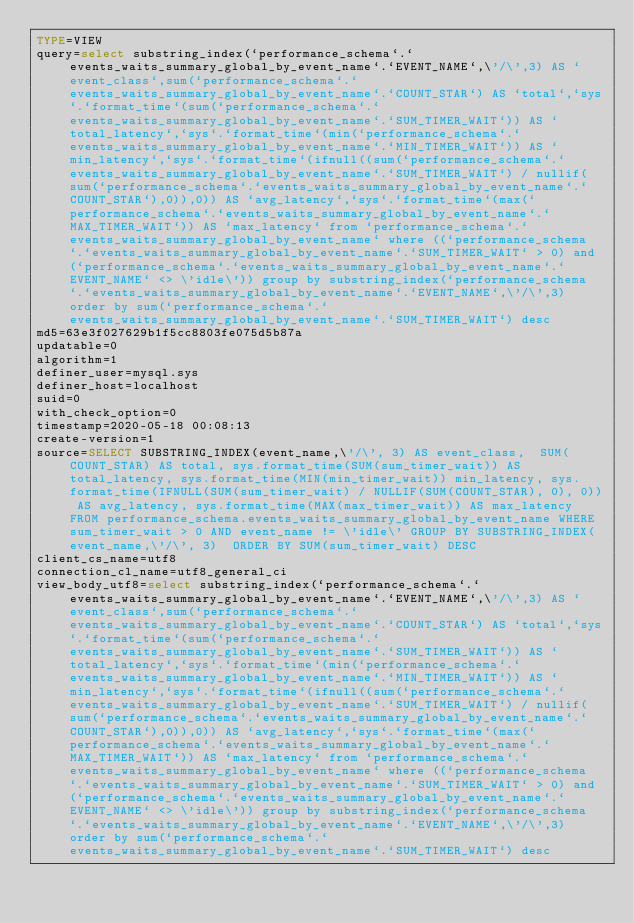Convert code to text. <code><loc_0><loc_0><loc_500><loc_500><_VisualBasic_>TYPE=VIEW
query=select substring_index(`performance_schema`.`events_waits_summary_global_by_event_name`.`EVENT_NAME`,\'/\',3) AS `event_class`,sum(`performance_schema`.`events_waits_summary_global_by_event_name`.`COUNT_STAR`) AS `total`,`sys`.`format_time`(sum(`performance_schema`.`events_waits_summary_global_by_event_name`.`SUM_TIMER_WAIT`)) AS `total_latency`,`sys`.`format_time`(min(`performance_schema`.`events_waits_summary_global_by_event_name`.`MIN_TIMER_WAIT`)) AS `min_latency`,`sys`.`format_time`(ifnull((sum(`performance_schema`.`events_waits_summary_global_by_event_name`.`SUM_TIMER_WAIT`) / nullif(sum(`performance_schema`.`events_waits_summary_global_by_event_name`.`COUNT_STAR`),0)),0)) AS `avg_latency`,`sys`.`format_time`(max(`performance_schema`.`events_waits_summary_global_by_event_name`.`MAX_TIMER_WAIT`)) AS `max_latency` from `performance_schema`.`events_waits_summary_global_by_event_name` where ((`performance_schema`.`events_waits_summary_global_by_event_name`.`SUM_TIMER_WAIT` > 0) and (`performance_schema`.`events_waits_summary_global_by_event_name`.`EVENT_NAME` <> \'idle\')) group by substring_index(`performance_schema`.`events_waits_summary_global_by_event_name`.`EVENT_NAME`,\'/\',3) order by sum(`performance_schema`.`events_waits_summary_global_by_event_name`.`SUM_TIMER_WAIT`) desc
md5=63e3f027629b1f5cc8803fe075d5b87a
updatable=0
algorithm=1
definer_user=mysql.sys
definer_host=localhost
suid=0
with_check_option=0
timestamp=2020-05-18 00:08:13
create-version=1
source=SELECT SUBSTRING_INDEX(event_name,\'/\', 3) AS event_class,  SUM(COUNT_STAR) AS total, sys.format_time(SUM(sum_timer_wait)) AS total_latency, sys.format_time(MIN(min_timer_wait)) min_latency, sys.format_time(IFNULL(SUM(sum_timer_wait) / NULLIF(SUM(COUNT_STAR), 0), 0)) AS avg_latency, sys.format_time(MAX(max_timer_wait)) AS max_latency FROM performance_schema.events_waits_summary_global_by_event_name WHERE sum_timer_wait > 0 AND event_name != \'idle\' GROUP BY SUBSTRING_INDEX(event_name,\'/\', 3)  ORDER BY SUM(sum_timer_wait) DESC
client_cs_name=utf8
connection_cl_name=utf8_general_ci
view_body_utf8=select substring_index(`performance_schema`.`events_waits_summary_global_by_event_name`.`EVENT_NAME`,\'/\',3) AS `event_class`,sum(`performance_schema`.`events_waits_summary_global_by_event_name`.`COUNT_STAR`) AS `total`,`sys`.`format_time`(sum(`performance_schema`.`events_waits_summary_global_by_event_name`.`SUM_TIMER_WAIT`)) AS `total_latency`,`sys`.`format_time`(min(`performance_schema`.`events_waits_summary_global_by_event_name`.`MIN_TIMER_WAIT`)) AS `min_latency`,`sys`.`format_time`(ifnull((sum(`performance_schema`.`events_waits_summary_global_by_event_name`.`SUM_TIMER_WAIT`) / nullif(sum(`performance_schema`.`events_waits_summary_global_by_event_name`.`COUNT_STAR`),0)),0)) AS `avg_latency`,`sys`.`format_time`(max(`performance_schema`.`events_waits_summary_global_by_event_name`.`MAX_TIMER_WAIT`)) AS `max_latency` from `performance_schema`.`events_waits_summary_global_by_event_name` where ((`performance_schema`.`events_waits_summary_global_by_event_name`.`SUM_TIMER_WAIT` > 0) and (`performance_schema`.`events_waits_summary_global_by_event_name`.`EVENT_NAME` <> \'idle\')) group by substring_index(`performance_schema`.`events_waits_summary_global_by_event_name`.`EVENT_NAME`,\'/\',3) order by sum(`performance_schema`.`events_waits_summary_global_by_event_name`.`SUM_TIMER_WAIT`) desc
</code> 